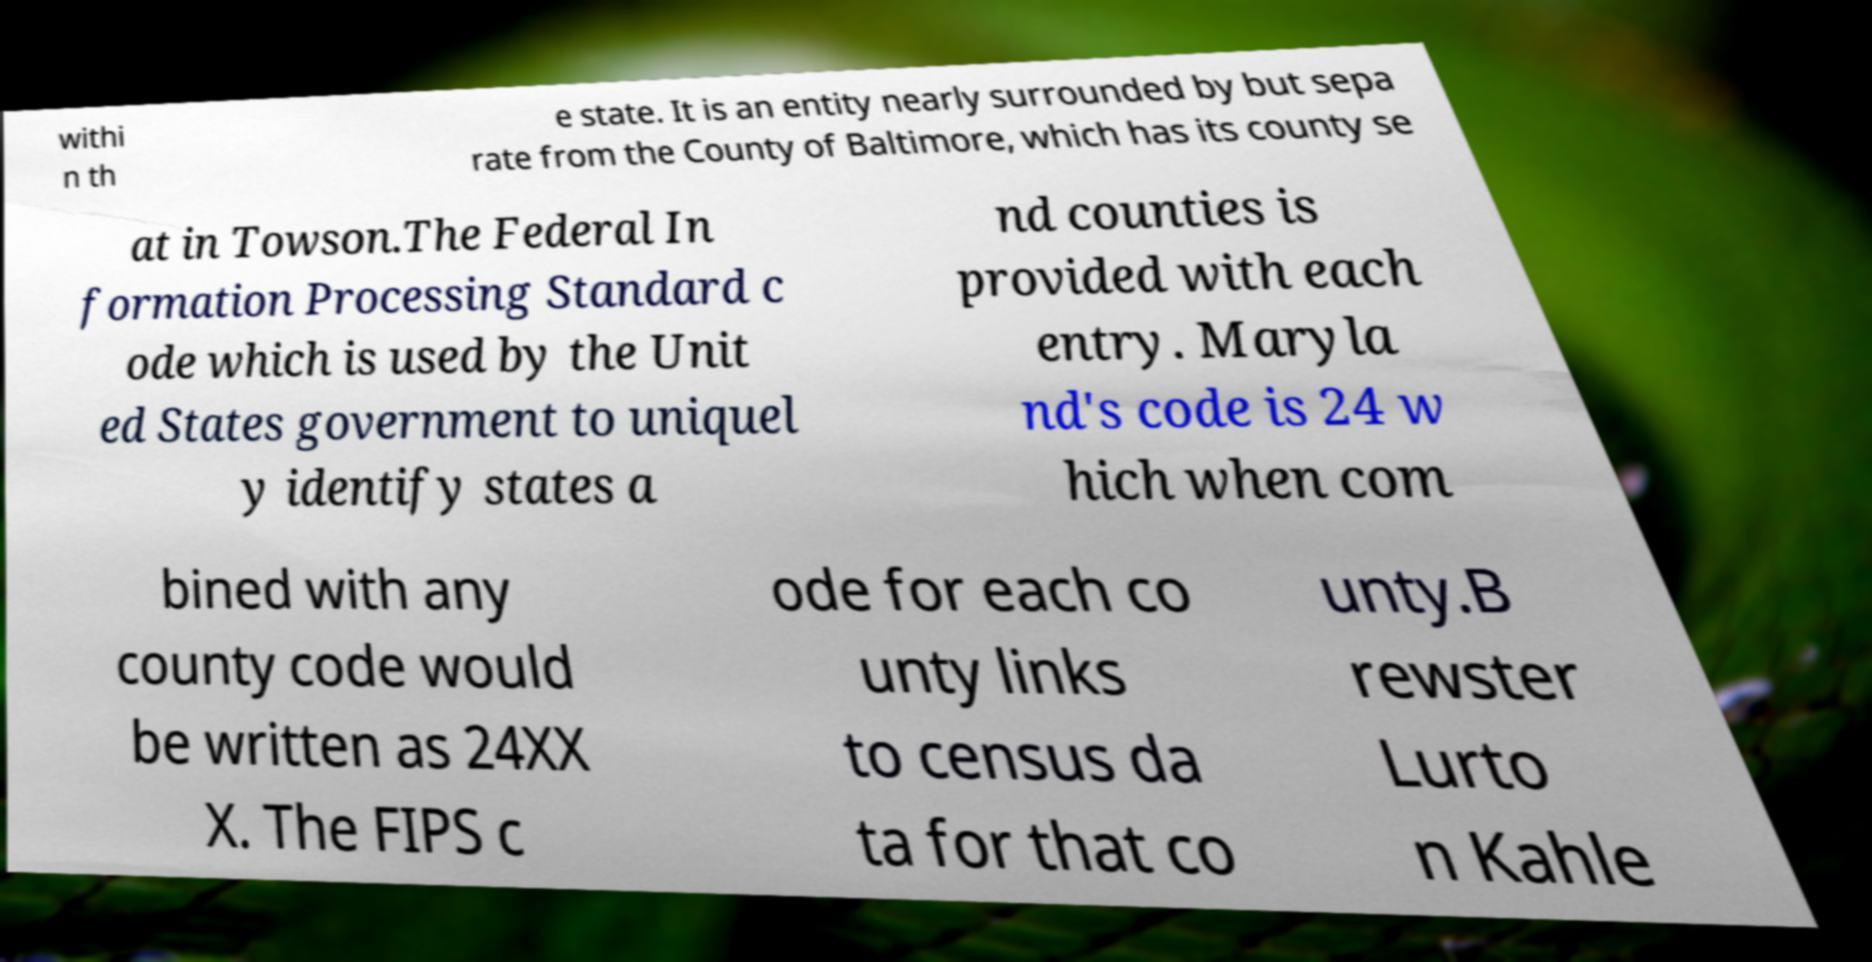Can you read and provide the text displayed in the image?This photo seems to have some interesting text. Can you extract and type it out for me? withi n th e state. It is an entity nearly surrounded by but sepa rate from the County of Baltimore, which has its county se at in Towson.The Federal In formation Processing Standard c ode which is used by the Unit ed States government to uniquel y identify states a nd counties is provided with each entry. Maryla nd's code is 24 w hich when com bined with any county code would be written as 24XX X. The FIPS c ode for each co unty links to census da ta for that co unty.B rewster Lurto n Kahle 